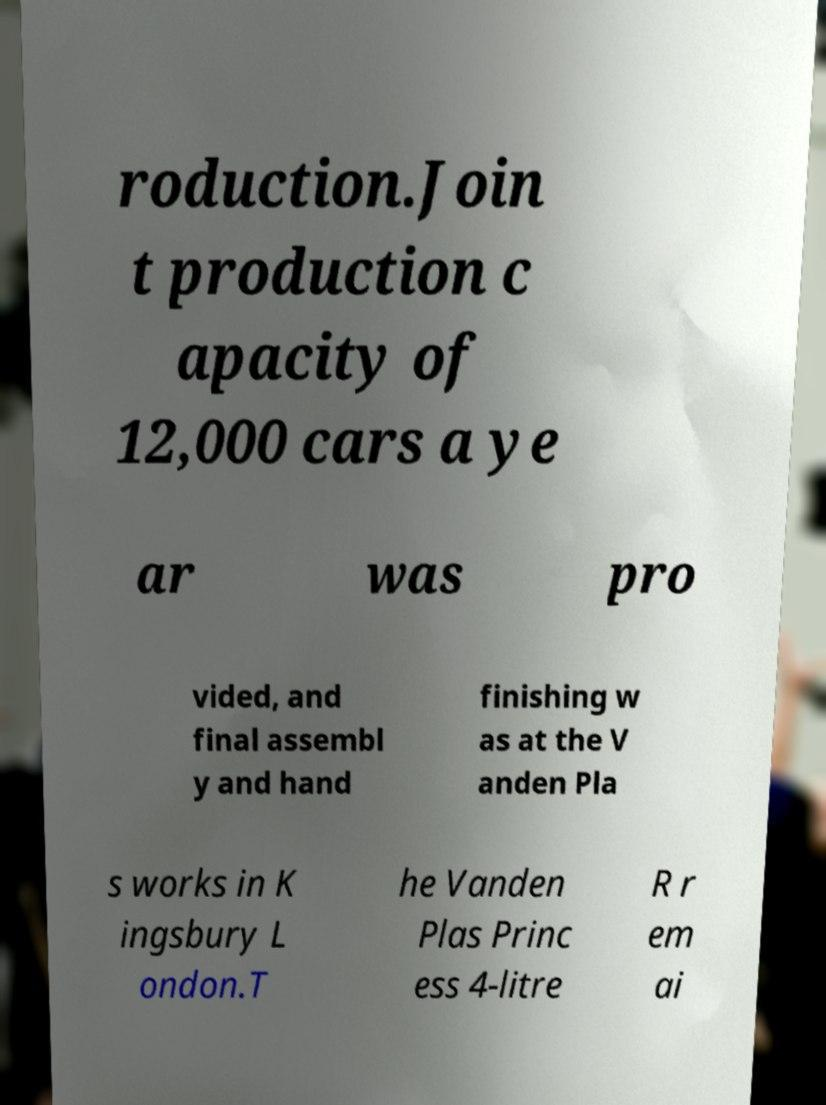Please identify and transcribe the text found in this image. roduction.Join t production c apacity of 12,000 cars a ye ar was pro vided, and final assembl y and hand finishing w as at the V anden Pla s works in K ingsbury L ondon.T he Vanden Plas Princ ess 4-litre R r em ai 